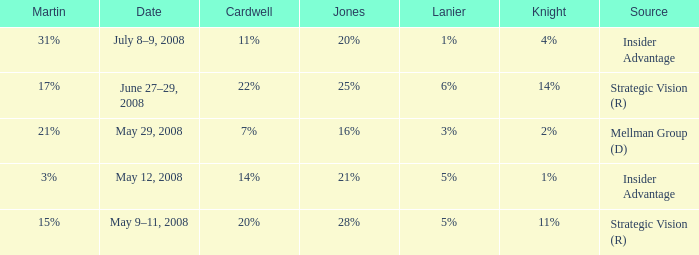What cardwell has an insider advantage and a knight of 1% 14%. 